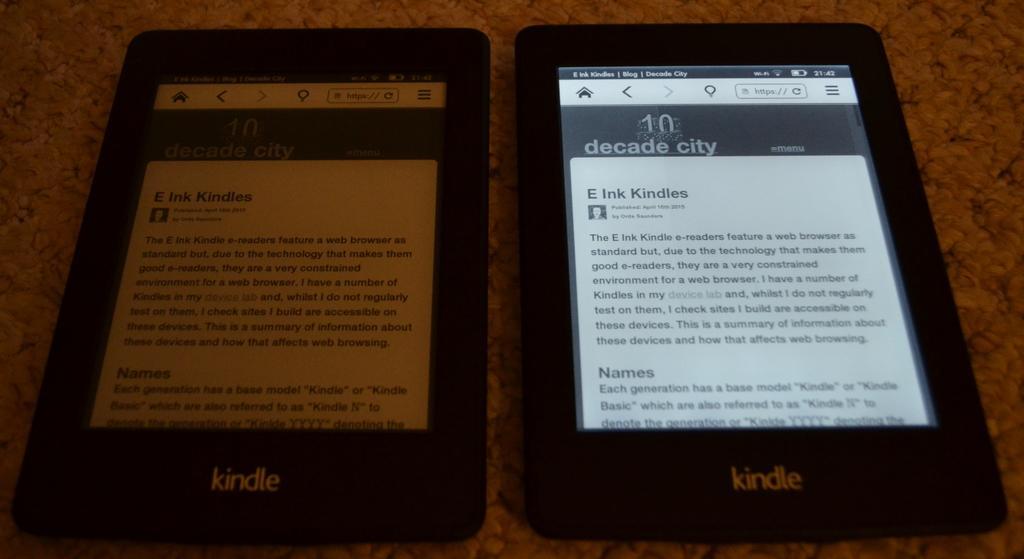Please provide a concise description of this image. In this image I can see two electronic devices. These are on the brown color surface. 